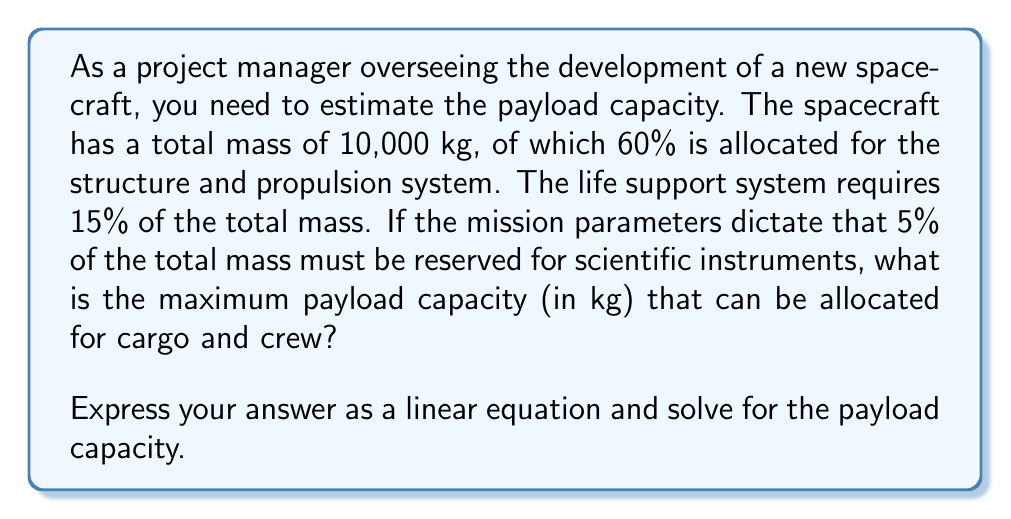Teach me how to tackle this problem. Let's approach this step-by-step:

1) First, let's define our variables:
   Let $x$ be the payload capacity in kg.

2) Now, let's break down the mass allocation:
   - Structure and propulsion: 60% of 10,000 kg = $0.60 \times 10,000 = 6,000$ kg
   - Life support system: 15% of 10,000 kg = $0.15 \times 10,000 = 1,500$ kg
   - Scientific instruments: 5% of 10,000 kg = $0.05 \times 10,000 = 500$ kg

3) The total mass of the spacecraft must equal the sum of all components:

   $$ 10,000 = 6,000 + 1,500 + 500 + x $$

4) This is our linear equation. Let's solve for $x$:

   $$ 10,000 = 8,000 + x $$
   $$ x = 10,000 - 8,000 $$
   $$ x = 2,000 $$

5) Therefore, the maximum payload capacity for cargo and crew is 2,000 kg.

6) We can verify this by checking that all components sum to the total mass:
   $$ 6,000 + 1,500 + 500 + 2,000 = 10,000 $$

This confirms our solution is correct.
Answer: The maximum payload capacity for cargo and crew is 2,000 kg.

The linear equation is:
$$ x = 10,000 - (6,000 + 1,500 + 500) $$
where $x$ represents the payload capacity in kg. 